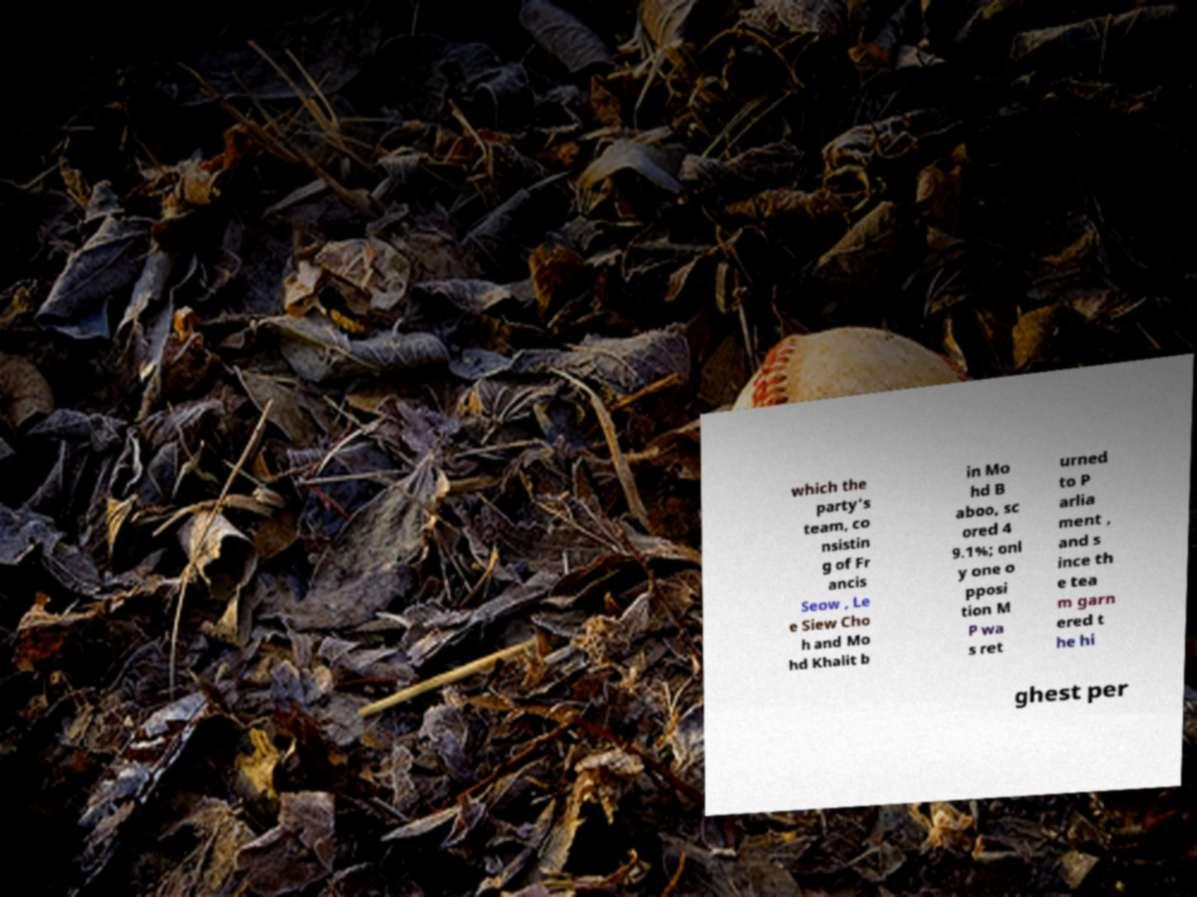Can you read and provide the text displayed in the image?This photo seems to have some interesting text. Can you extract and type it out for me? which the party's team, co nsistin g of Fr ancis Seow , Le e Siew Cho h and Mo hd Khalit b in Mo hd B aboo, sc ored 4 9.1%; onl y one o pposi tion M P wa s ret urned to P arlia ment , and s ince th e tea m garn ered t he hi ghest per 